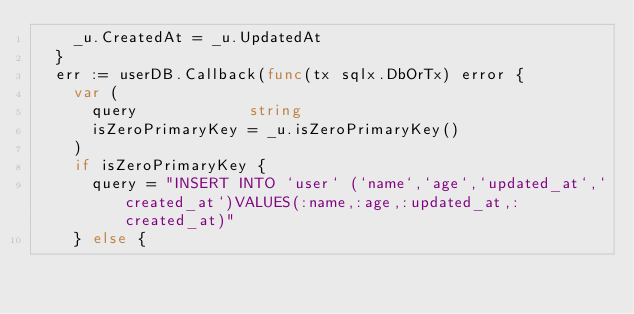<code> <loc_0><loc_0><loc_500><loc_500><_Go_>		_u.CreatedAt = _u.UpdatedAt
	}
	err := userDB.Callback(func(tx sqlx.DbOrTx) error {
		var (
			query            string
			isZeroPrimaryKey = _u.isZeroPrimaryKey()
		)
		if isZeroPrimaryKey {
			query = "INSERT INTO `user` (`name`,`age`,`updated_at`,`created_at`)VALUES(:name,:age,:updated_at,:created_at)"
		} else {</code> 